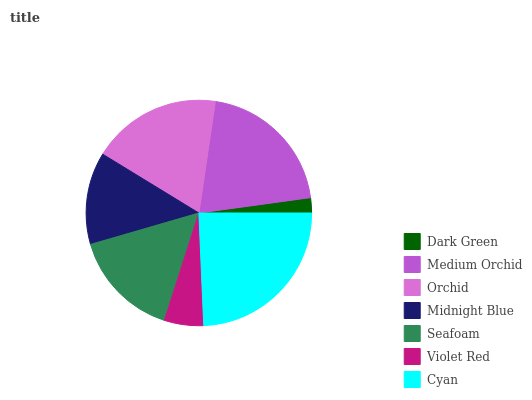Is Dark Green the minimum?
Answer yes or no. Yes. Is Cyan the maximum?
Answer yes or no. Yes. Is Medium Orchid the minimum?
Answer yes or no. No. Is Medium Orchid the maximum?
Answer yes or no. No. Is Medium Orchid greater than Dark Green?
Answer yes or no. Yes. Is Dark Green less than Medium Orchid?
Answer yes or no. Yes. Is Dark Green greater than Medium Orchid?
Answer yes or no. No. Is Medium Orchid less than Dark Green?
Answer yes or no. No. Is Seafoam the high median?
Answer yes or no. Yes. Is Seafoam the low median?
Answer yes or no. Yes. Is Medium Orchid the high median?
Answer yes or no. No. Is Midnight Blue the low median?
Answer yes or no. No. 